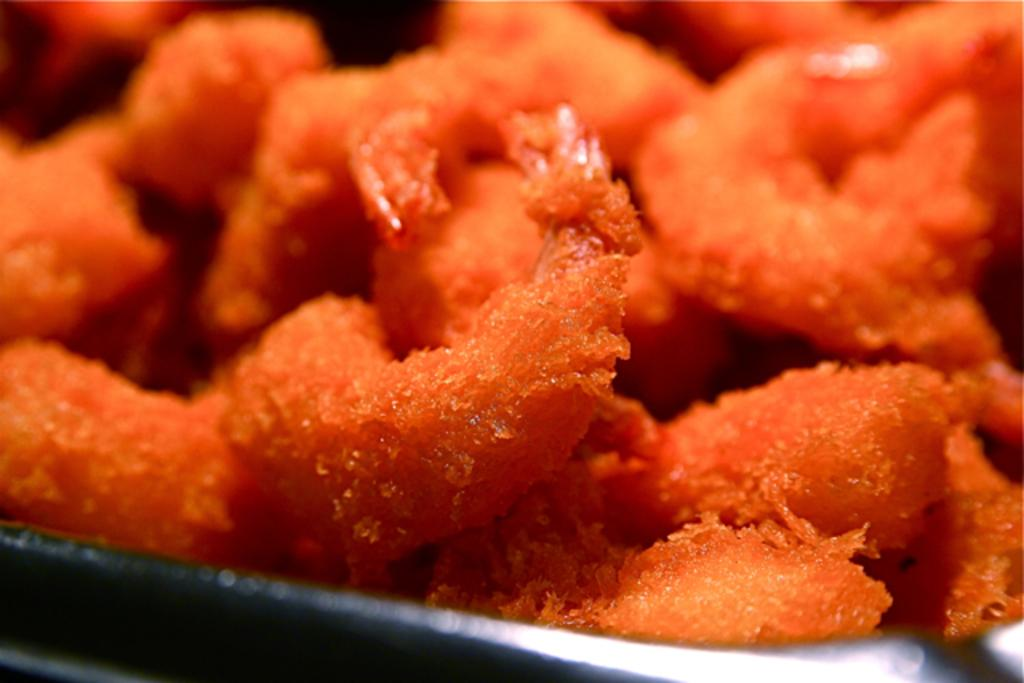What is the main subject of the image? There is a food item in the image. How is the food item presented in the image? The food item is on a plate. Can you tell me how many giraffes are visible in the image? There are no giraffes present in the image. What type of appliance is being used to prepare the food item in the image? There is no appliance visible in the image; it only shows the food item on a plate. 